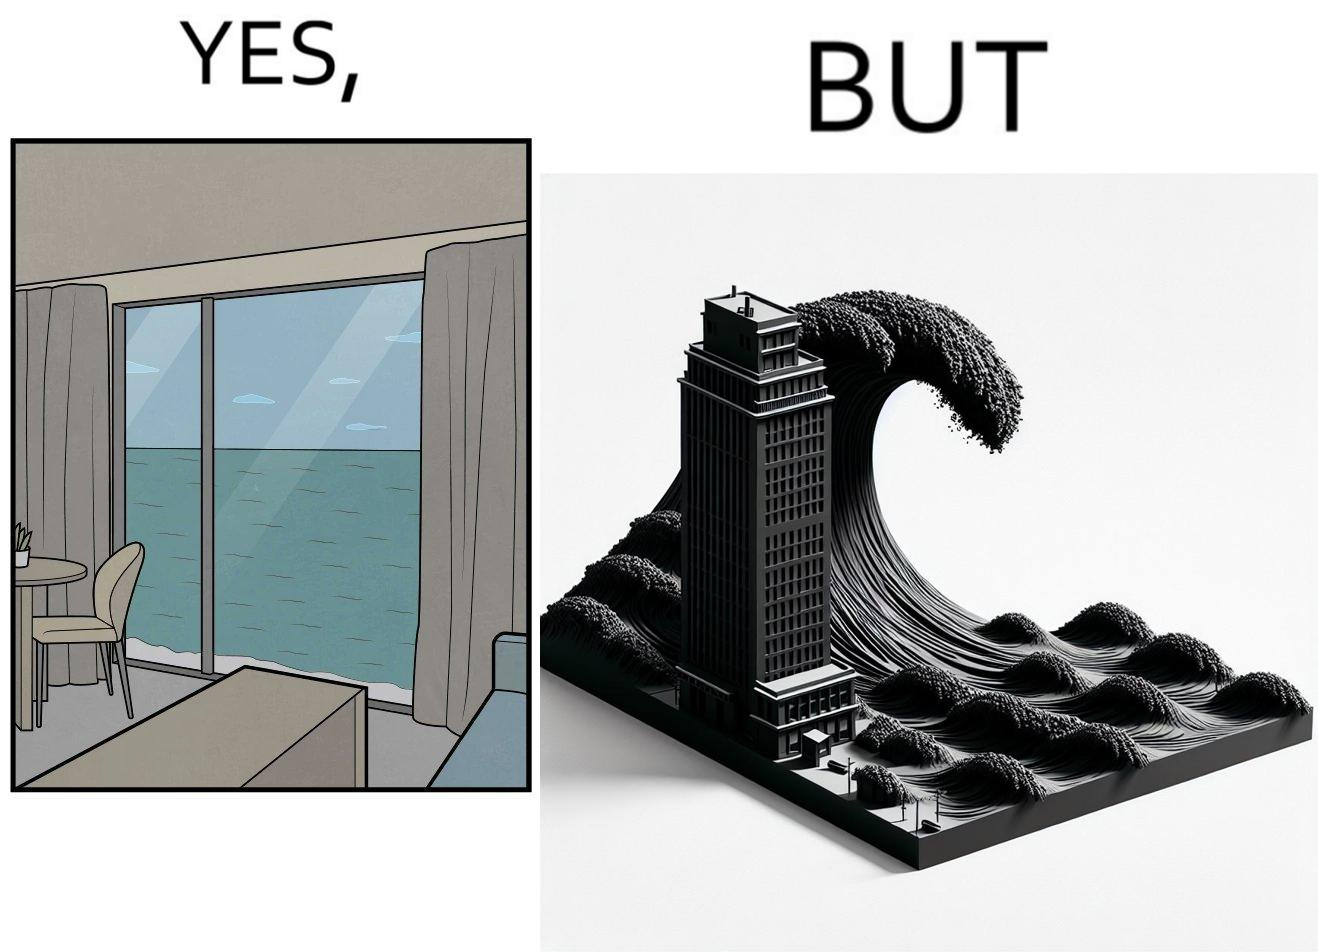What is shown in the left half versus the right half of this image? In the left part of the image: a room with a sea-facing door In the right part of the image: high waves in the sea twice of the height of the building near the sea 